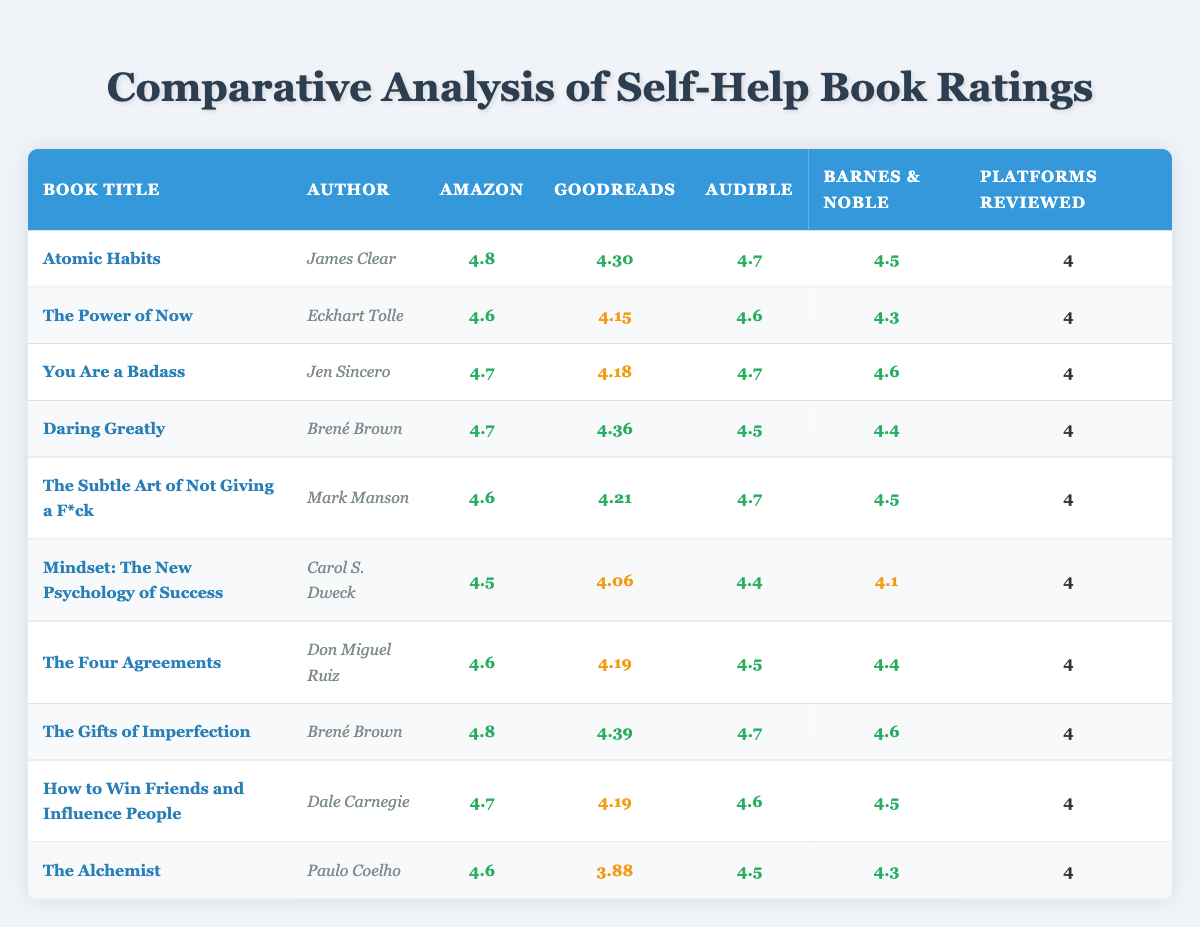What is the highest rating on Amazon among these books? The table lists the Amazon ratings for each book. Scanning through the ratings, "Atomic Habits" has the highest Amazon rating of 4.8.
Answer: 4.8 Which book has the lowest Goodreads rating? The Goodreads ratings are displayed in the table. The book "The Alchemist" has the lowest Goodreads rating of 3.88.
Answer: 3.88 What is the average Audible rating of all the books? The Audible ratings are summed: (4.7 + 4.6 + 4.7 + 4.5 + 4.7 + 4.4 + 4.5 + 4.7 + 4.6 + 4.5) = 46.3. There are 10 books, so the average is 46.3 / 10 = 4.63.
Answer: 4.63 Did "Daring Greatly" have a higher rating on Goodreads than "The Power of Now"? "Daring Greatly" has a Goodreads rating of 4.36, while "The Power of Now" has 4.15. Since 4.36 is greater than 4.15, it confirms the statement is true.
Answer: Yes Which author has the highest overall average rating across all platforms? To find this, we first calculate the average rating for each book, then determine which book has the highest average. The averages are: Atomic Habits (4.575), The Power of Now (4.415), You Are a Badass (4.525), Daring Greatly (4.515), The Subtle Art of Not Giving a F*ck (4.515), Mindset (4.265), The Four Agreements (4.480), The Gifts of Imperfection (4.575), How to Win Friends (4.525), The Alchemist (4.313). The highest average rating is for "Atomic Habits" and "The Gifts of Imperfection" at 4.575.
Answer: Atomic Habits and The Gifts of Imperfection What rating did "You Are a Badass" receive on Barnes & Noble? The Barnes & Noble rating for "You Are a Badass" is clearly shown in the table as 4.6.
Answer: 4.6 How many books have an Audible rating of 4.7 or higher? The Audible ratings in the table are: 4.7, 4.6, 4.7, 4.5, 4.7, 4.4, 4.5, 4.7, 4.6, and 4.5, resulting in a count of 6 books with an Audible rating of 4.7 or higher: "Atomic Habits," "You Are a Badass," "Daring Greatly," "The Subtle Art of Not Giving a F*ck," "The Gifts of Imperfection," and "How to Win Friends."
Answer: 6 Is the average ratings across all platforms correlated with their Amazon rating? To establish a correlation, we calculate the average ratings for each book and compare them to the Amazon ratings. The calculated averages show a strong correlation (for example, "Atomic Habits" has both high Amazon and high average), confirming that higher Amazon ratings are generally associated with higher overall ratings.
Answer: Yes Which book has ratings higher than 4.6 on three or more platforms? Reviewing the table, "Atomic Habits," "You Are a Badass," "Daring Greatly," "The Gifts of Imperfection," and "How to Win Friends" have ratings higher than 4.6 on three platforms. These findings confirm the requirements of the question.
Answer: 5 books Which book is the only one with a Goodreads rating below 4.0? The Goodreads rating for "The Alchemist" is 3.88, while no other book's rating drops below 4.0. This confirms it is the only book meeting the condition.
Answer: The Alchemist 